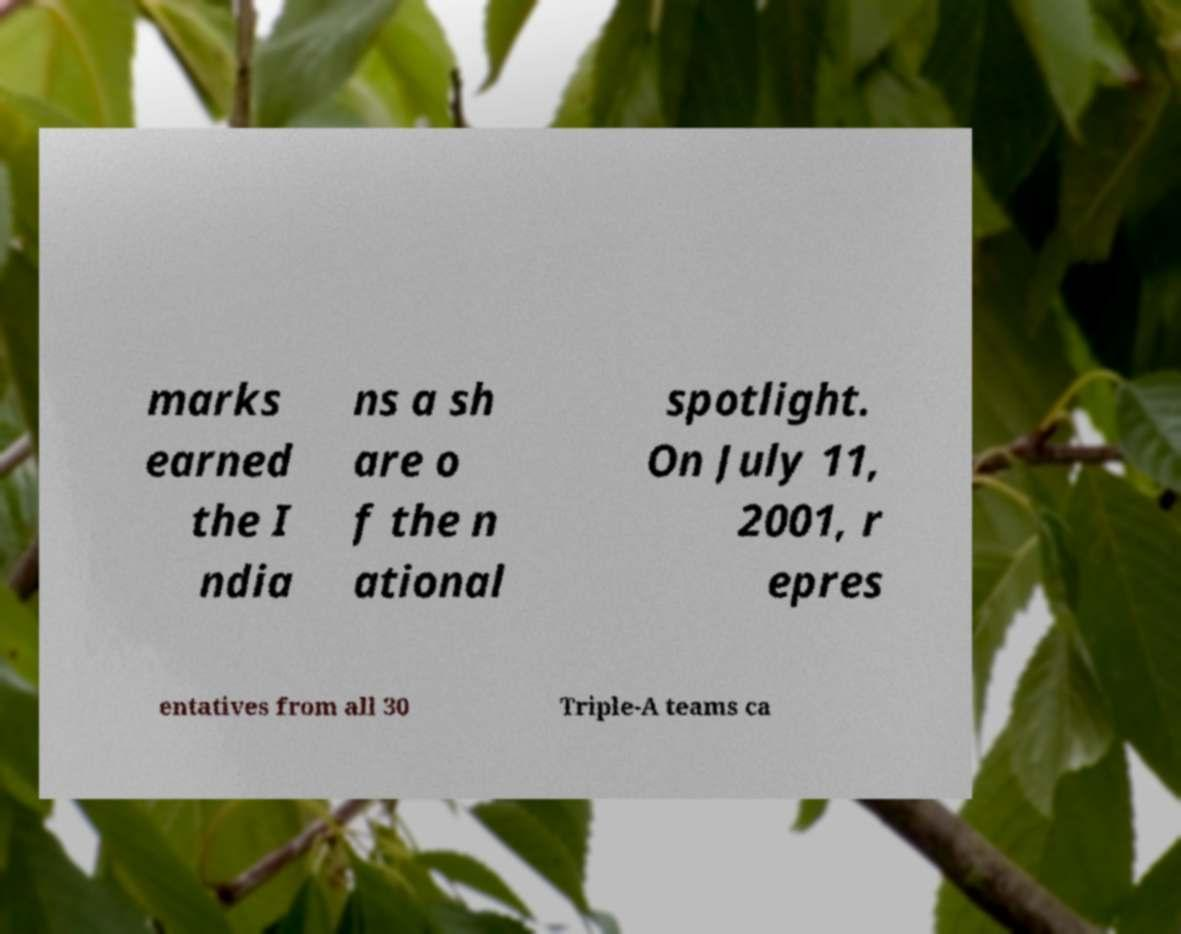Please identify and transcribe the text found in this image. marks earned the I ndia ns a sh are o f the n ational spotlight. On July 11, 2001, r epres entatives from all 30 Triple-A teams ca 